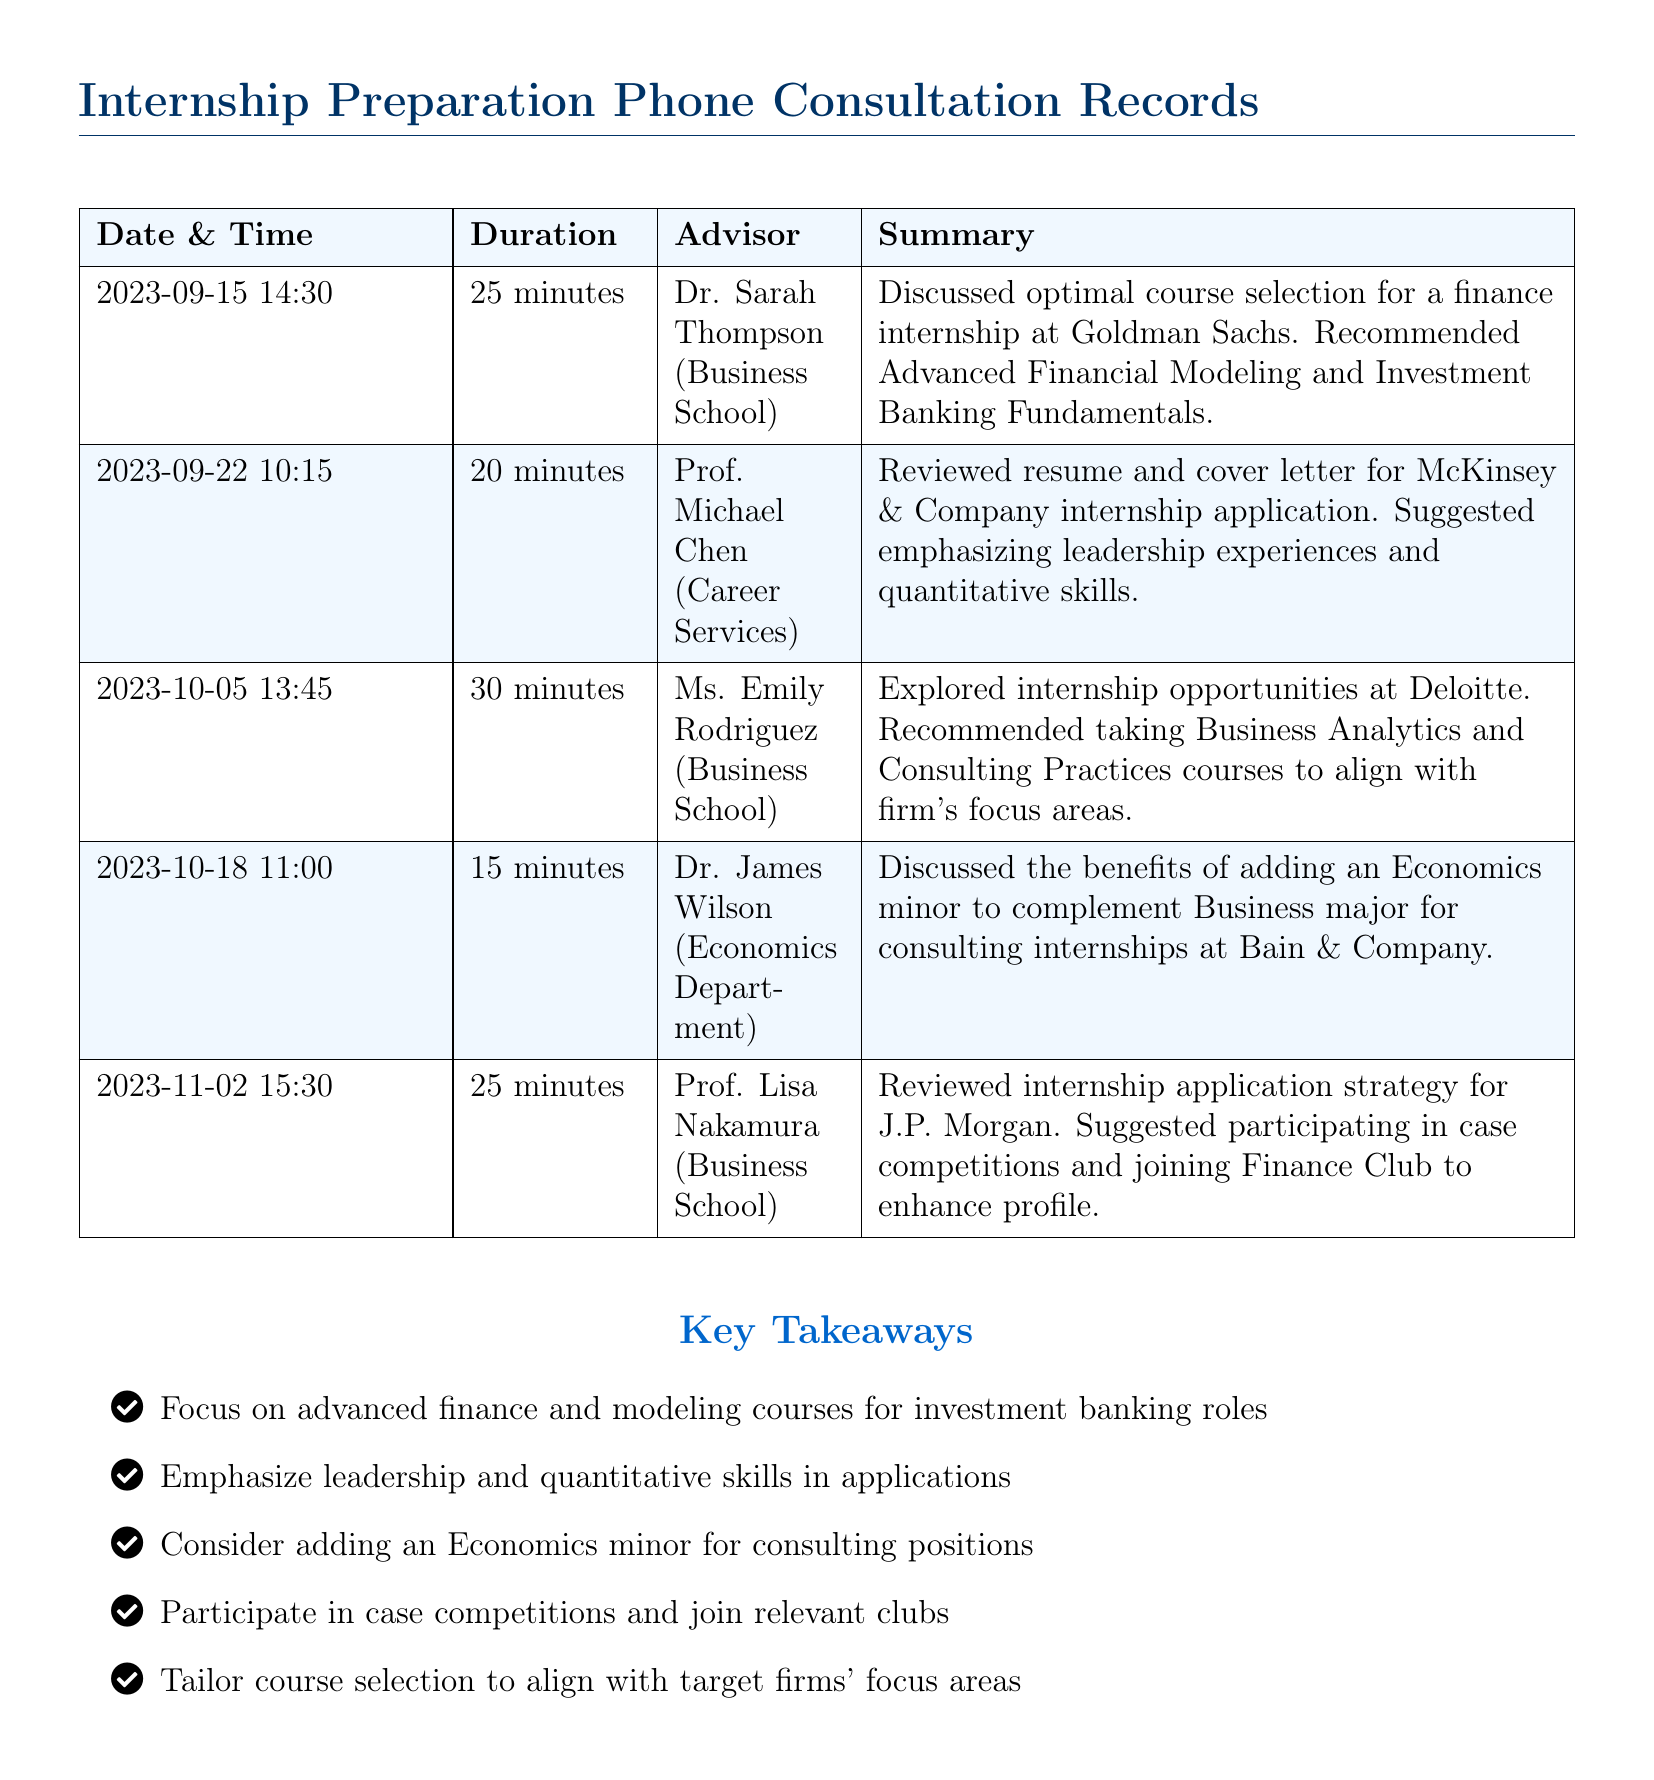What date did the consultation with Dr. Sarah Thompson occur? The consultation with Dr. Sarah Thompson took place on September 15, 2023.
Answer: September 15, 2023 How long was the consultation with Prof. Michael Chen? The duration of the consultation with Prof. Michael Chen was 20 minutes.
Answer: 20 minutes Which course was recommended for a finance internship at Goldman Sachs? Dr. Sarah Thompson recommended Advanced Financial Modeling for the finance internship.
Answer: Advanced Financial Modeling What is the main focus of the courses recommended by Ms. Emily Rodriguez? The courses recommended by Ms. Emily Rodriguez focus on Business Analytics and Consulting Practices to align with Deloitte's needs.
Answer: Business Analytics and Consulting Practices What minor was suggested by Dr. James Wilson to complement the Business major? Dr. James Wilson suggested adding an Economics minor to complement the Business major.
Answer: Economics minor Which firm’s internship did Prof. Lisa Nakamura provide application strategy for? Prof. Lisa Nakamura provided internship application strategy for J.P. Morgan.
Answer: J.P. Morgan What specific skills did Prof. Michael Chen suggest highlighting in applications? Prof. Michael Chen suggested emphasizing leadership and quantitative skills in applications.
Answer: Leadership and quantitative skills How many advisors were consulted in total? The document lists five different advisors who were consulted.
Answer: Five What key activity was recommended to enhance applications for J.P. Morgan? Participating in case competitions was recommended as a key activity for J.P. Morgan applications.
Answer: Case competitions 